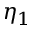Convert formula to latex. <formula><loc_0><loc_0><loc_500><loc_500>\eta _ { 1 }</formula> 